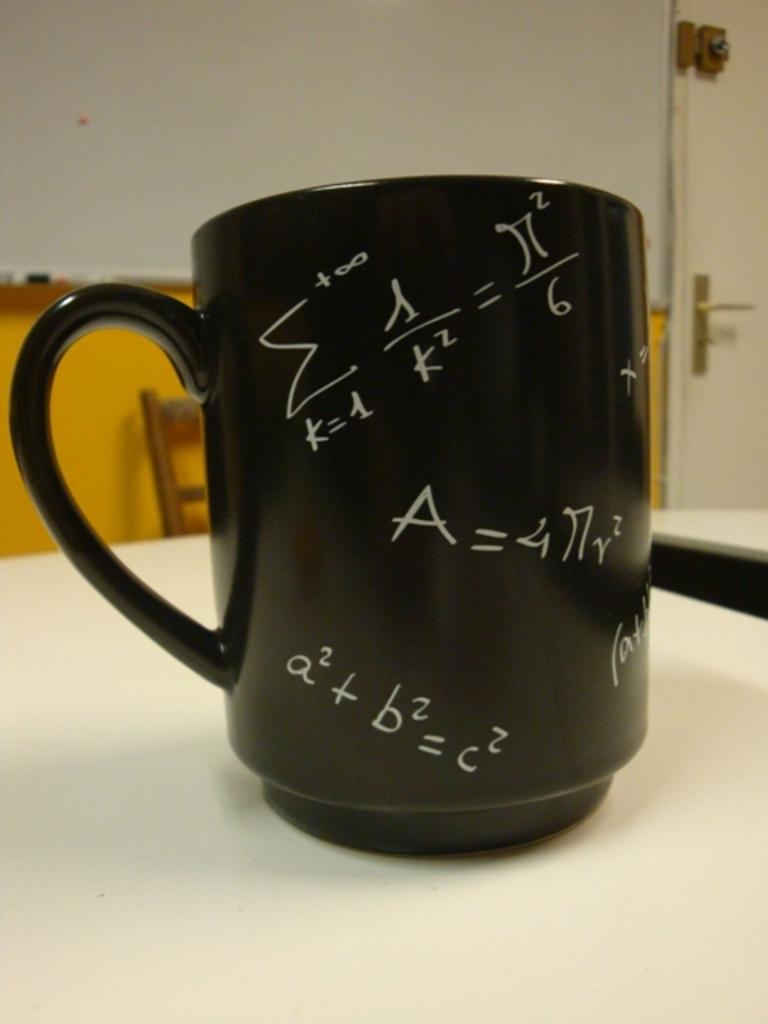<image>
Create a compact narrative representing the image presented. A coffee mug with various mathematical equations on it, including the Pythagorean theorem. 